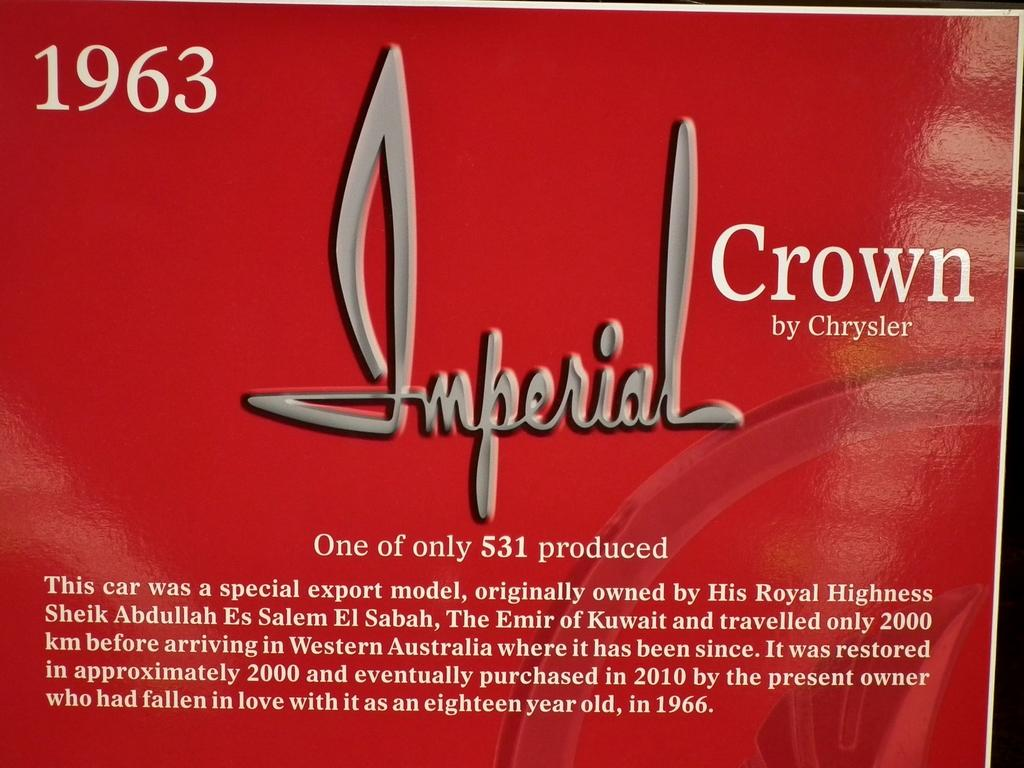<image>
Present a compact description of the photo's key features. 1963 Imperial Crown by Chrysler that has the text: One of only 531 produced. 